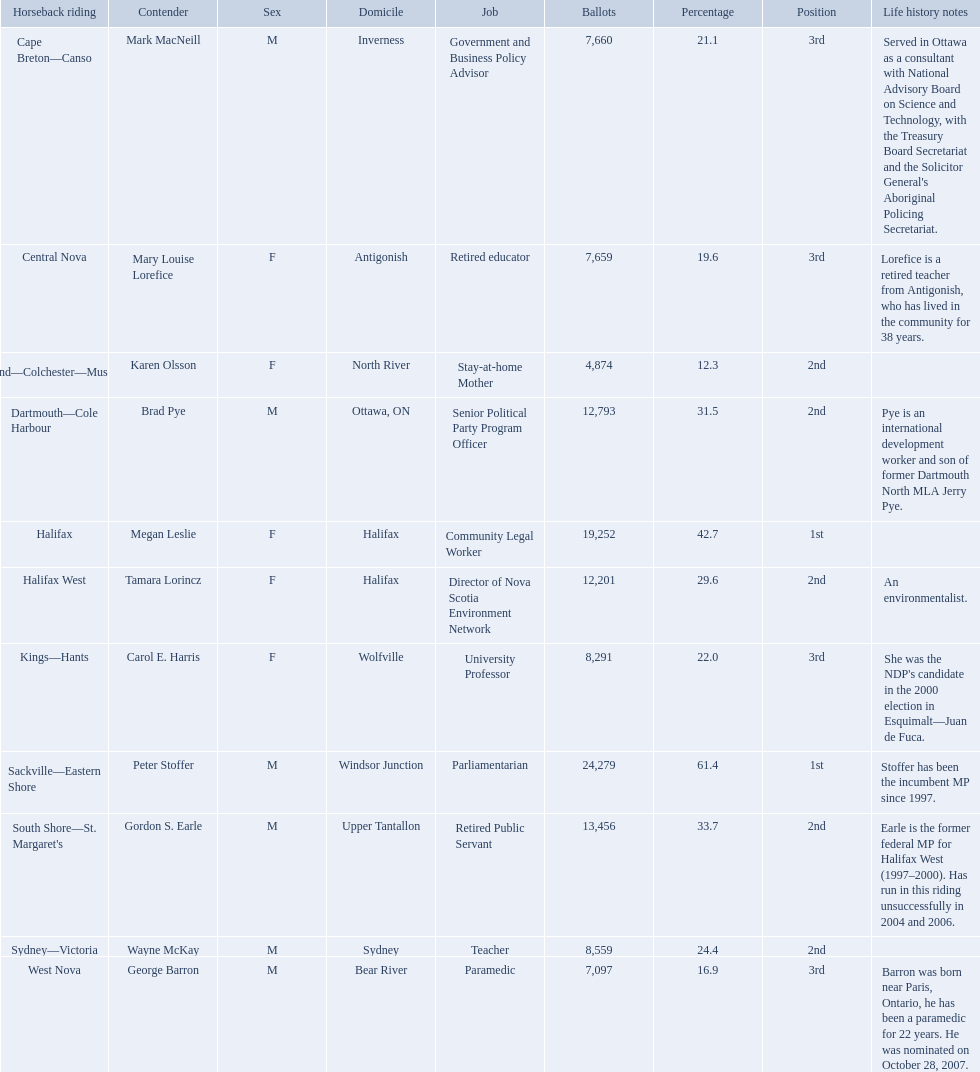Who were all of the new democratic party candidates during the 2008 canadian federal election? Mark MacNeill, Mary Louise Lorefice, Karen Olsson, Brad Pye, Megan Leslie, Tamara Lorincz, Carol E. Harris, Peter Stoffer, Gordon S. Earle, Wayne McKay, George Barron. And between mark macneill and karen olsson, which candidate received more votes? Mark MacNeill. 